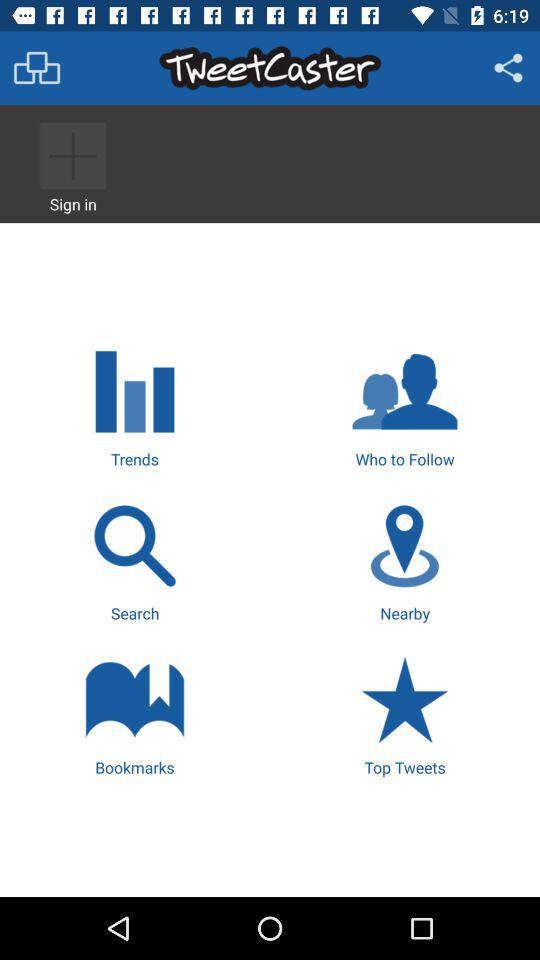What is the name of the application? The name of the application is "TweetCaster". 